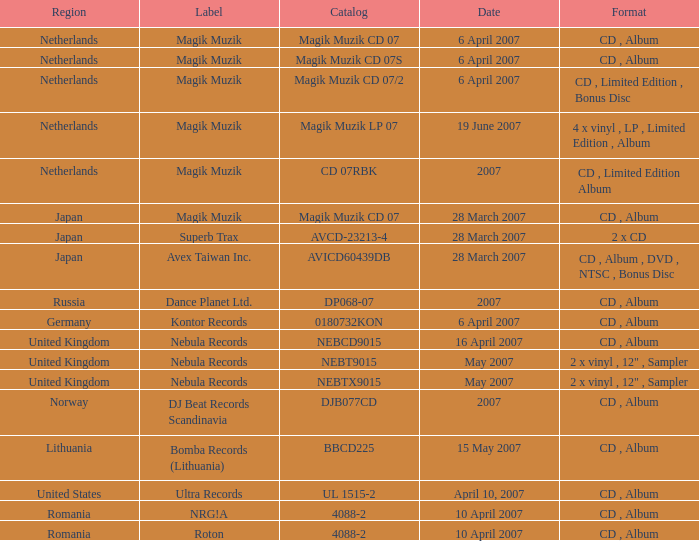From which region is the album with release date of 19 June 2007? Netherlands. Can you parse all the data within this table? {'header': ['Region', 'Label', 'Catalog', 'Date', 'Format'], 'rows': [['Netherlands', 'Magik Muzik', 'Magik Muzik CD 07', '6 April 2007', 'CD , Album'], ['Netherlands', 'Magik Muzik', 'Magik Muzik CD 07S', '6 April 2007', 'CD , Album'], ['Netherlands', 'Magik Muzik', 'Magik Muzik CD 07/2', '6 April 2007', 'CD , Limited Edition , Bonus Disc'], ['Netherlands', 'Magik Muzik', 'Magik Muzik LP 07', '19 June 2007', '4 x vinyl , LP , Limited Edition , Album'], ['Netherlands', 'Magik Muzik', 'CD 07RBK', '2007', 'CD , Limited Edition Album'], ['Japan', 'Magik Muzik', 'Magik Muzik CD 07', '28 March 2007', 'CD , Album'], ['Japan', 'Superb Trax', 'AVCD-23213-4', '28 March 2007', '2 x CD'], ['Japan', 'Avex Taiwan Inc.', 'AVICD60439DB', '28 March 2007', 'CD , Album , DVD , NTSC , Bonus Disc'], ['Russia', 'Dance Planet Ltd.', 'DP068-07', '2007', 'CD , Album'], ['Germany', 'Kontor Records', '0180732KON', '6 April 2007', 'CD , Album'], ['United Kingdom', 'Nebula Records', 'NEBCD9015', '16 April 2007', 'CD , Album'], ['United Kingdom', 'Nebula Records', 'NEBT9015', 'May 2007', '2 x vinyl , 12" , Sampler'], ['United Kingdom', 'Nebula Records', 'NEBTX9015', 'May 2007', '2 x vinyl , 12" , Sampler'], ['Norway', 'DJ Beat Records Scandinavia', 'DJB077CD', '2007', 'CD , Album'], ['Lithuania', 'Bomba Records (Lithuania)', 'BBCD225', '15 May 2007', 'CD , Album'], ['United States', 'Ultra Records', 'UL 1515-2', 'April 10, 2007', 'CD , Album'], ['Romania', 'NRG!A', '4088-2', '10 April 2007', 'CD , Album'], ['Romania', 'Roton', '4088-2', '10 April 2007', 'CD , Album']]} 